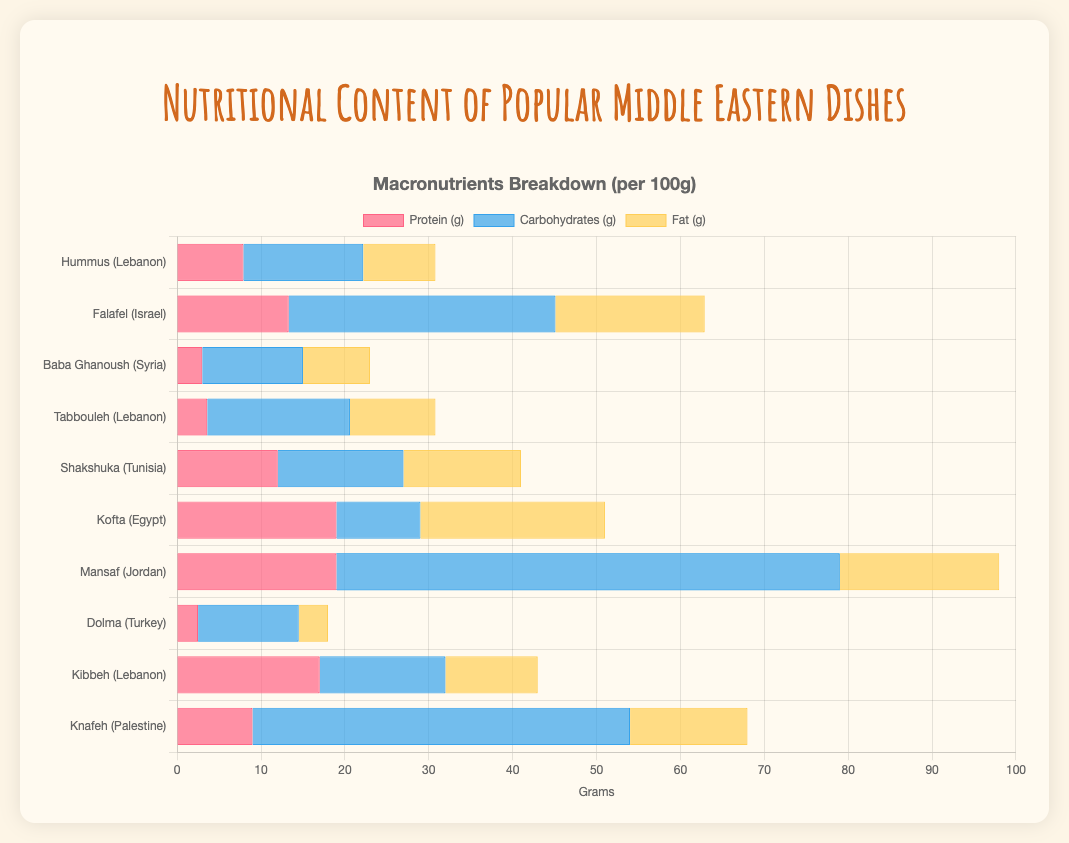Which dish has the highest protein content? Look at the bars representing protein content for each dish. Identify which bar is the longest.
Answer: Mansaf Which country has the highest average fat content in its dishes? Calculate the average fat content for dishes from each country by summing their fat contents and dividing by the number of dishes from that country. Compare these averages to find the highest one.
Answer: Lebanon Which dish has lower protein content: Hummus or Dolma? Find the protein content bars for both Hummus and Dolma and compare their lengths to determine which is shorter.
Answer: Dolma What is the total carbohydrate content of Falafel and Shakshuka combined? Add the carbohydrate content for Falafel and Shakshuka.
Answer: 46.8 If you were to combine the fat content of Kibbeh and Kofta, how much fat would you have? Add the fat content values for Kibbeh and Kofta.
Answer: 33 Which dish from Lebanon has the lowest calorie count? Identify all dishes from Lebanon first. Then compare their calorie values to find the lowest one.
Answer: Hummus Compare the carbohydrate content in Baba Ghanoush and Tabbouleh. Which one has more carbohydrates? Look at the carbohydrate content bars for Baba Ghanoush and Tabbouleh, and determine which is longer.
Answer: Tabbouleh Calculate the average protein content for the dishes in the figure. Sum the protein content of all dishes, then divide by the number of dishes (10 in this case).
Answer: 10.83 Which dish from Palestine has the highest fat content? Identify dishes from Palestine and compare their fat content bars to find the longest one.
Answer: Knafeh Which dish has more calories: Kofta or Knafeh? Compare the calorie values for Kofta and Knafeh to see which one is higher.
Answer: Knafeh 